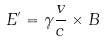Convert formula to latex. <formula><loc_0><loc_0><loc_500><loc_500>E ^ { \prime } = \gamma \frac { v } { c } \times B</formula> 